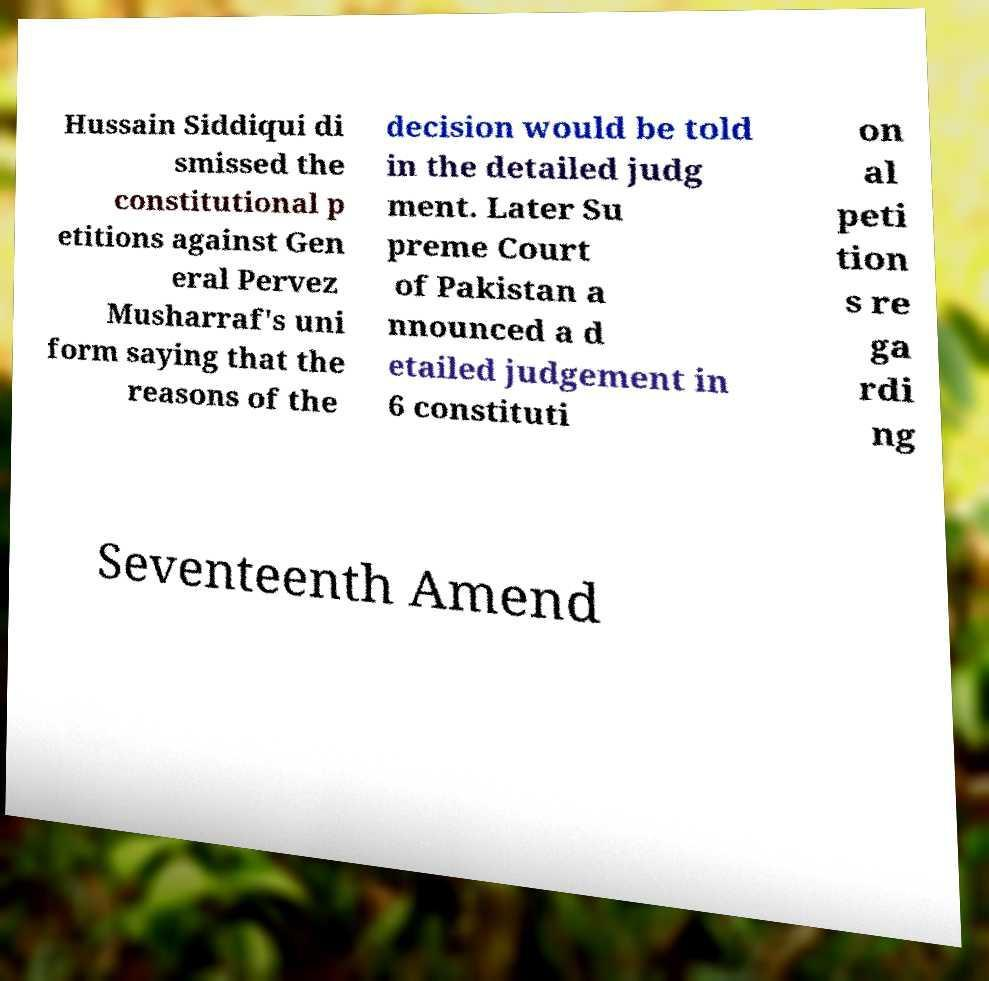For documentation purposes, I need the text within this image transcribed. Could you provide that? Hussain Siddiqui di smissed the constitutional p etitions against Gen eral Pervez Musharraf's uni form saying that the reasons of the decision would be told in the detailed judg ment. Later Su preme Court of Pakistan a nnounced a d etailed judgement in 6 constituti on al peti tion s re ga rdi ng Seventeenth Amend 